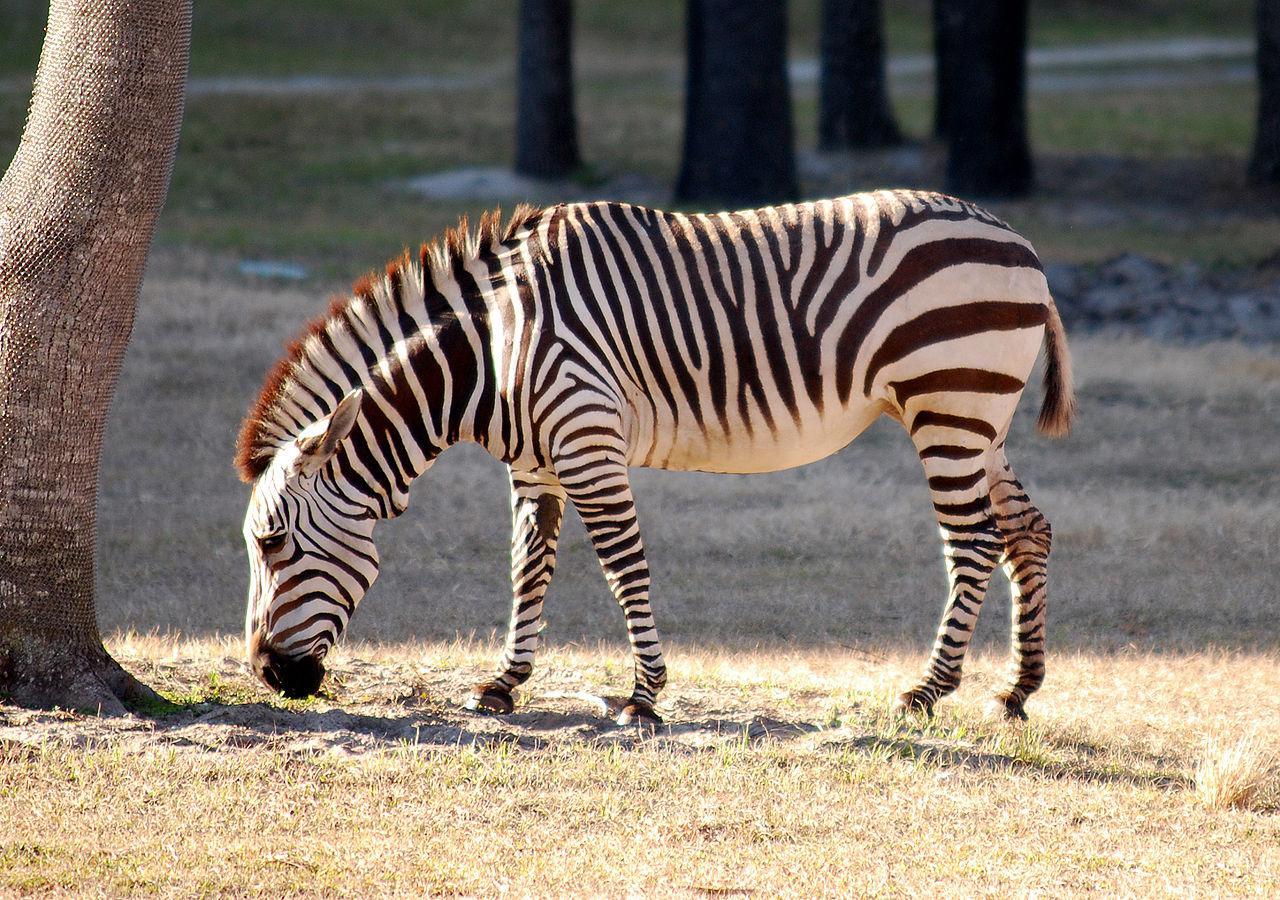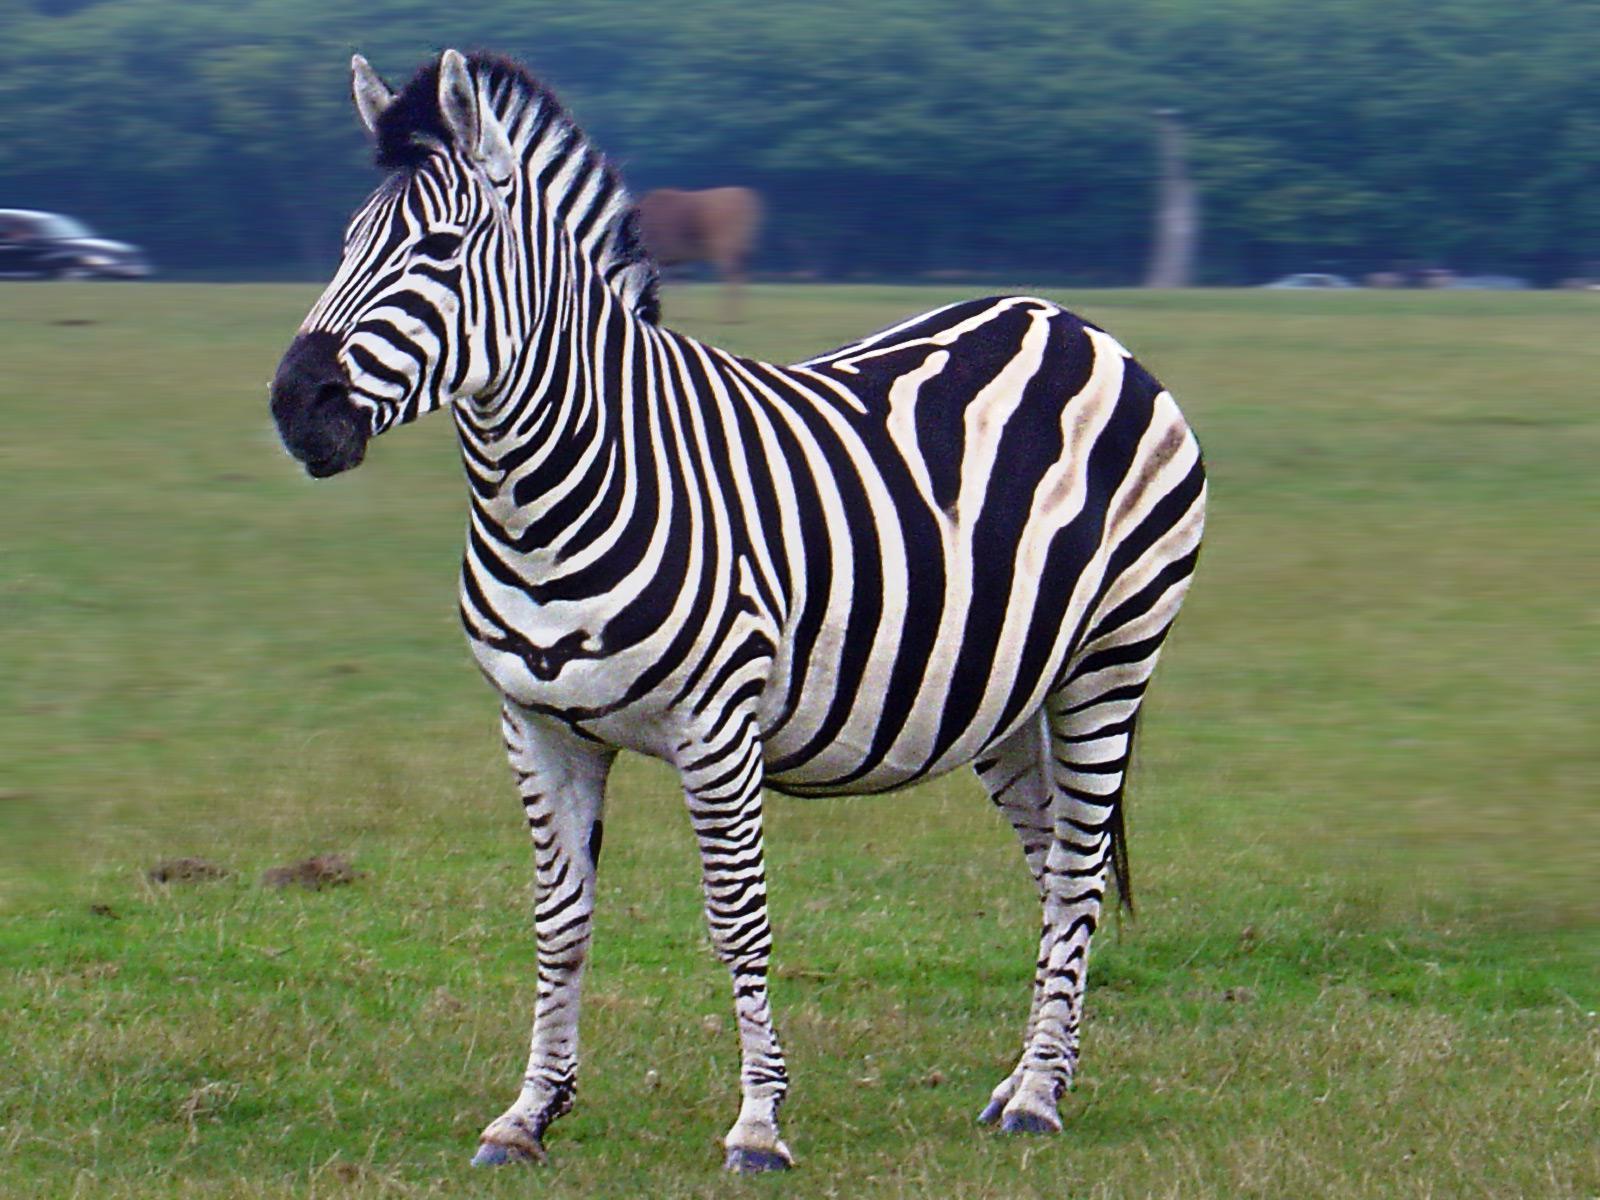The first image is the image on the left, the second image is the image on the right. For the images shown, is this caption "There is a baby zebra standing next to an adult zebra." true? Answer yes or no. No. The first image is the image on the left, the second image is the image on the right. Considering the images on both sides, is "The zebras in both pictures are facing left." valid? Answer yes or no. Yes. 